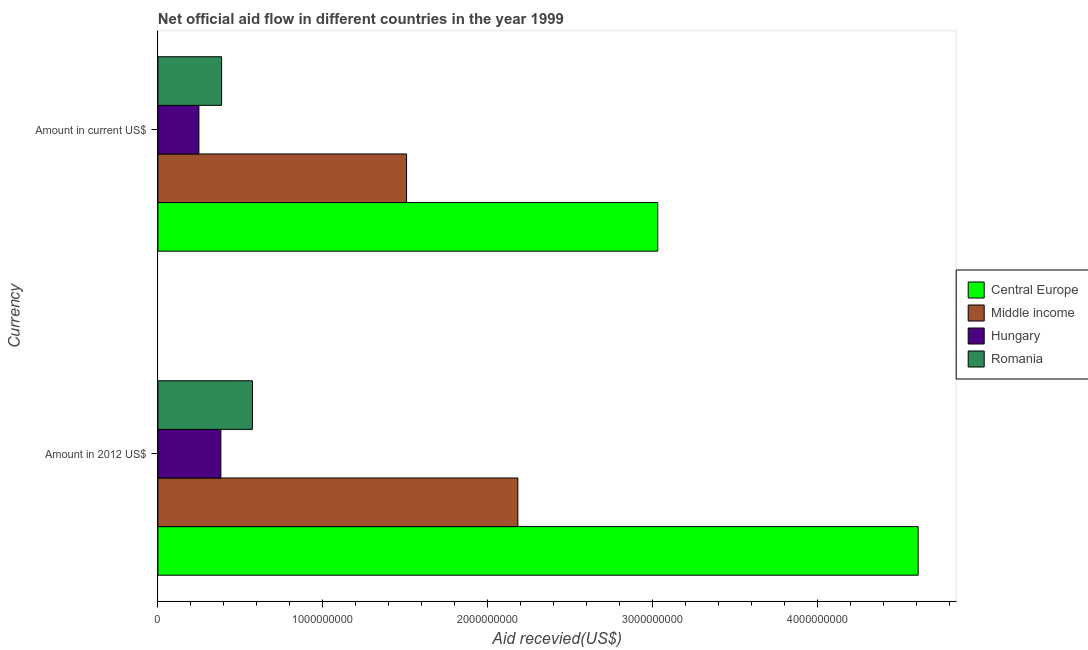How many different coloured bars are there?
Your response must be concise. 4. How many groups of bars are there?
Offer a terse response. 2. Are the number of bars per tick equal to the number of legend labels?
Provide a succinct answer. Yes. Are the number of bars on each tick of the Y-axis equal?
Offer a terse response. Yes. How many bars are there on the 2nd tick from the top?
Keep it short and to the point. 4. How many bars are there on the 1st tick from the bottom?
Offer a terse response. 4. What is the label of the 2nd group of bars from the top?
Give a very brief answer. Amount in 2012 US$. What is the amount of aid received(expressed in 2012 us$) in Central Europe?
Provide a short and direct response. 4.61e+09. Across all countries, what is the maximum amount of aid received(expressed in us$)?
Offer a very short reply. 3.03e+09. Across all countries, what is the minimum amount of aid received(expressed in 2012 us$)?
Provide a short and direct response. 3.82e+08. In which country was the amount of aid received(expressed in 2012 us$) maximum?
Provide a succinct answer. Central Europe. In which country was the amount of aid received(expressed in 2012 us$) minimum?
Your answer should be compact. Hungary. What is the total amount of aid received(expressed in 2012 us$) in the graph?
Offer a very short reply. 7.75e+09. What is the difference between the amount of aid received(expressed in 2012 us$) in Hungary and that in Middle income?
Offer a terse response. -1.80e+09. What is the difference between the amount of aid received(expressed in 2012 us$) in Middle income and the amount of aid received(expressed in us$) in Romania?
Provide a short and direct response. 1.80e+09. What is the average amount of aid received(expressed in us$) per country?
Keep it short and to the point. 1.29e+09. What is the difference between the amount of aid received(expressed in 2012 us$) and amount of aid received(expressed in us$) in Middle income?
Provide a short and direct response. 6.75e+08. What is the ratio of the amount of aid received(expressed in 2012 us$) in Central Europe to that in Romania?
Provide a succinct answer. 8.04. Is the amount of aid received(expressed in 2012 us$) in Romania less than that in Hungary?
Offer a terse response. No. What does the 2nd bar from the top in Amount in current US$ represents?
Your answer should be very brief. Hungary. What does the 4th bar from the bottom in Amount in current US$ represents?
Your answer should be compact. Romania. How many bars are there?
Make the answer very short. 8. Are all the bars in the graph horizontal?
Make the answer very short. Yes. Are the values on the major ticks of X-axis written in scientific E-notation?
Your response must be concise. No. Does the graph contain grids?
Your response must be concise. No. Where does the legend appear in the graph?
Your response must be concise. Center right. How many legend labels are there?
Your answer should be compact. 4. What is the title of the graph?
Offer a terse response. Net official aid flow in different countries in the year 1999. Does "Burkina Faso" appear as one of the legend labels in the graph?
Provide a succinct answer. No. What is the label or title of the X-axis?
Offer a terse response. Aid recevied(US$). What is the label or title of the Y-axis?
Provide a succinct answer. Currency. What is the Aid recevied(US$) of Central Europe in Amount in 2012 US$?
Provide a short and direct response. 4.61e+09. What is the Aid recevied(US$) of Middle income in Amount in 2012 US$?
Keep it short and to the point. 2.18e+09. What is the Aid recevied(US$) in Hungary in Amount in 2012 US$?
Give a very brief answer. 3.82e+08. What is the Aid recevied(US$) in Romania in Amount in 2012 US$?
Offer a very short reply. 5.74e+08. What is the Aid recevied(US$) in Central Europe in Amount in current US$?
Provide a succinct answer. 3.03e+09. What is the Aid recevied(US$) in Middle income in Amount in current US$?
Provide a short and direct response. 1.51e+09. What is the Aid recevied(US$) of Hungary in Amount in current US$?
Offer a terse response. 2.49e+08. What is the Aid recevied(US$) of Romania in Amount in current US$?
Provide a short and direct response. 3.86e+08. Across all Currency, what is the maximum Aid recevied(US$) of Central Europe?
Make the answer very short. 4.61e+09. Across all Currency, what is the maximum Aid recevied(US$) of Middle income?
Your answer should be very brief. 2.18e+09. Across all Currency, what is the maximum Aid recevied(US$) in Hungary?
Provide a succinct answer. 3.82e+08. Across all Currency, what is the maximum Aid recevied(US$) of Romania?
Give a very brief answer. 5.74e+08. Across all Currency, what is the minimum Aid recevied(US$) of Central Europe?
Make the answer very short. 3.03e+09. Across all Currency, what is the minimum Aid recevied(US$) of Middle income?
Ensure brevity in your answer.  1.51e+09. Across all Currency, what is the minimum Aid recevied(US$) of Hungary?
Keep it short and to the point. 2.49e+08. Across all Currency, what is the minimum Aid recevied(US$) of Romania?
Keep it short and to the point. 3.86e+08. What is the total Aid recevied(US$) of Central Europe in the graph?
Your answer should be very brief. 7.64e+09. What is the total Aid recevied(US$) of Middle income in the graph?
Provide a short and direct response. 3.69e+09. What is the total Aid recevied(US$) in Hungary in the graph?
Provide a succinct answer. 6.31e+08. What is the total Aid recevied(US$) of Romania in the graph?
Your answer should be compact. 9.60e+08. What is the difference between the Aid recevied(US$) of Central Europe in Amount in 2012 US$ and that in Amount in current US$?
Provide a succinct answer. 1.58e+09. What is the difference between the Aid recevied(US$) of Middle income in Amount in 2012 US$ and that in Amount in current US$?
Your answer should be very brief. 6.75e+08. What is the difference between the Aid recevied(US$) of Hungary in Amount in 2012 US$ and that in Amount in current US$?
Provide a short and direct response. 1.33e+08. What is the difference between the Aid recevied(US$) in Romania in Amount in 2012 US$ and that in Amount in current US$?
Your answer should be very brief. 1.87e+08. What is the difference between the Aid recevied(US$) of Central Europe in Amount in 2012 US$ and the Aid recevied(US$) of Middle income in Amount in current US$?
Provide a short and direct response. 3.10e+09. What is the difference between the Aid recevied(US$) of Central Europe in Amount in 2012 US$ and the Aid recevied(US$) of Hungary in Amount in current US$?
Make the answer very short. 4.36e+09. What is the difference between the Aid recevied(US$) of Central Europe in Amount in 2012 US$ and the Aid recevied(US$) of Romania in Amount in current US$?
Give a very brief answer. 4.23e+09. What is the difference between the Aid recevied(US$) of Middle income in Amount in 2012 US$ and the Aid recevied(US$) of Hungary in Amount in current US$?
Make the answer very short. 1.93e+09. What is the difference between the Aid recevied(US$) of Middle income in Amount in 2012 US$ and the Aid recevied(US$) of Romania in Amount in current US$?
Provide a short and direct response. 1.80e+09. What is the difference between the Aid recevied(US$) of Hungary in Amount in 2012 US$ and the Aid recevied(US$) of Romania in Amount in current US$?
Give a very brief answer. -4.38e+06. What is the average Aid recevied(US$) of Central Europe per Currency?
Provide a succinct answer. 3.82e+09. What is the average Aid recevied(US$) in Middle income per Currency?
Make the answer very short. 1.85e+09. What is the average Aid recevied(US$) of Hungary per Currency?
Make the answer very short. 3.15e+08. What is the average Aid recevied(US$) of Romania per Currency?
Your answer should be very brief. 4.80e+08. What is the difference between the Aid recevied(US$) of Central Europe and Aid recevied(US$) of Middle income in Amount in 2012 US$?
Provide a succinct answer. 2.43e+09. What is the difference between the Aid recevied(US$) in Central Europe and Aid recevied(US$) in Hungary in Amount in 2012 US$?
Provide a succinct answer. 4.23e+09. What is the difference between the Aid recevied(US$) in Central Europe and Aid recevied(US$) in Romania in Amount in 2012 US$?
Your response must be concise. 4.04e+09. What is the difference between the Aid recevied(US$) of Middle income and Aid recevied(US$) of Hungary in Amount in 2012 US$?
Your answer should be compact. 1.80e+09. What is the difference between the Aid recevied(US$) in Middle income and Aid recevied(US$) in Romania in Amount in 2012 US$?
Ensure brevity in your answer.  1.61e+09. What is the difference between the Aid recevied(US$) in Hungary and Aid recevied(US$) in Romania in Amount in 2012 US$?
Make the answer very short. -1.92e+08. What is the difference between the Aid recevied(US$) in Central Europe and Aid recevied(US$) in Middle income in Amount in current US$?
Offer a terse response. 1.52e+09. What is the difference between the Aid recevied(US$) of Central Europe and Aid recevied(US$) of Hungary in Amount in current US$?
Ensure brevity in your answer.  2.78e+09. What is the difference between the Aid recevied(US$) in Central Europe and Aid recevied(US$) in Romania in Amount in current US$?
Ensure brevity in your answer.  2.65e+09. What is the difference between the Aid recevied(US$) in Middle income and Aid recevied(US$) in Hungary in Amount in current US$?
Your answer should be compact. 1.26e+09. What is the difference between the Aid recevied(US$) of Middle income and Aid recevied(US$) of Romania in Amount in current US$?
Offer a terse response. 1.12e+09. What is the difference between the Aid recevied(US$) of Hungary and Aid recevied(US$) of Romania in Amount in current US$?
Your answer should be compact. -1.38e+08. What is the ratio of the Aid recevied(US$) of Central Europe in Amount in 2012 US$ to that in Amount in current US$?
Your answer should be very brief. 1.52. What is the ratio of the Aid recevied(US$) of Middle income in Amount in 2012 US$ to that in Amount in current US$?
Ensure brevity in your answer.  1.45. What is the ratio of the Aid recevied(US$) in Hungary in Amount in 2012 US$ to that in Amount in current US$?
Offer a very short reply. 1.54. What is the ratio of the Aid recevied(US$) in Romania in Amount in 2012 US$ to that in Amount in current US$?
Provide a short and direct response. 1.48. What is the difference between the highest and the second highest Aid recevied(US$) of Central Europe?
Ensure brevity in your answer.  1.58e+09. What is the difference between the highest and the second highest Aid recevied(US$) in Middle income?
Keep it short and to the point. 6.75e+08. What is the difference between the highest and the second highest Aid recevied(US$) in Hungary?
Provide a succinct answer. 1.33e+08. What is the difference between the highest and the second highest Aid recevied(US$) of Romania?
Your answer should be very brief. 1.87e+08. What is the difference between the highest and the lowest Aid recevied(US$) of Central Europe?
Your answer should be very brief. 1.58e+09. What is the difference between the highest and the lowest Aid recevied(US$) of Middle income?
Offer a terse response. 6.75e+08. What is the difference between the highest and the lowest Aid recevied(US$) in Hungary?
Provide a short and direct response. 1.33e+08. What is the difference between the highest and the lowest Aid recevied(US$) of Romania?
Offer a terse response. 1.87e+08. 